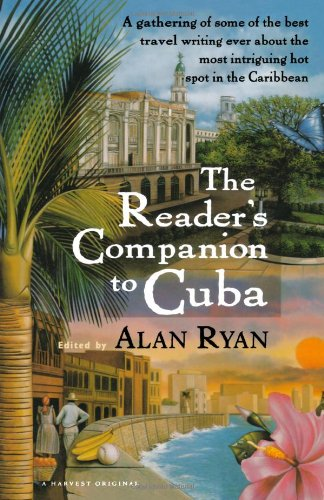Could you describe the imagery and elements on the book cover? The book cover features an array of images that evoke the spirit of Cuba: iconic architecture, palm trees, a vintage car, and the serene waterfront, encapsulating the diverse experiences one might encounter there. 